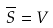Convert formula to latex. <formula><loc_0><loc_0><loc_500><loc_500>\overline { S } = V</formula> 